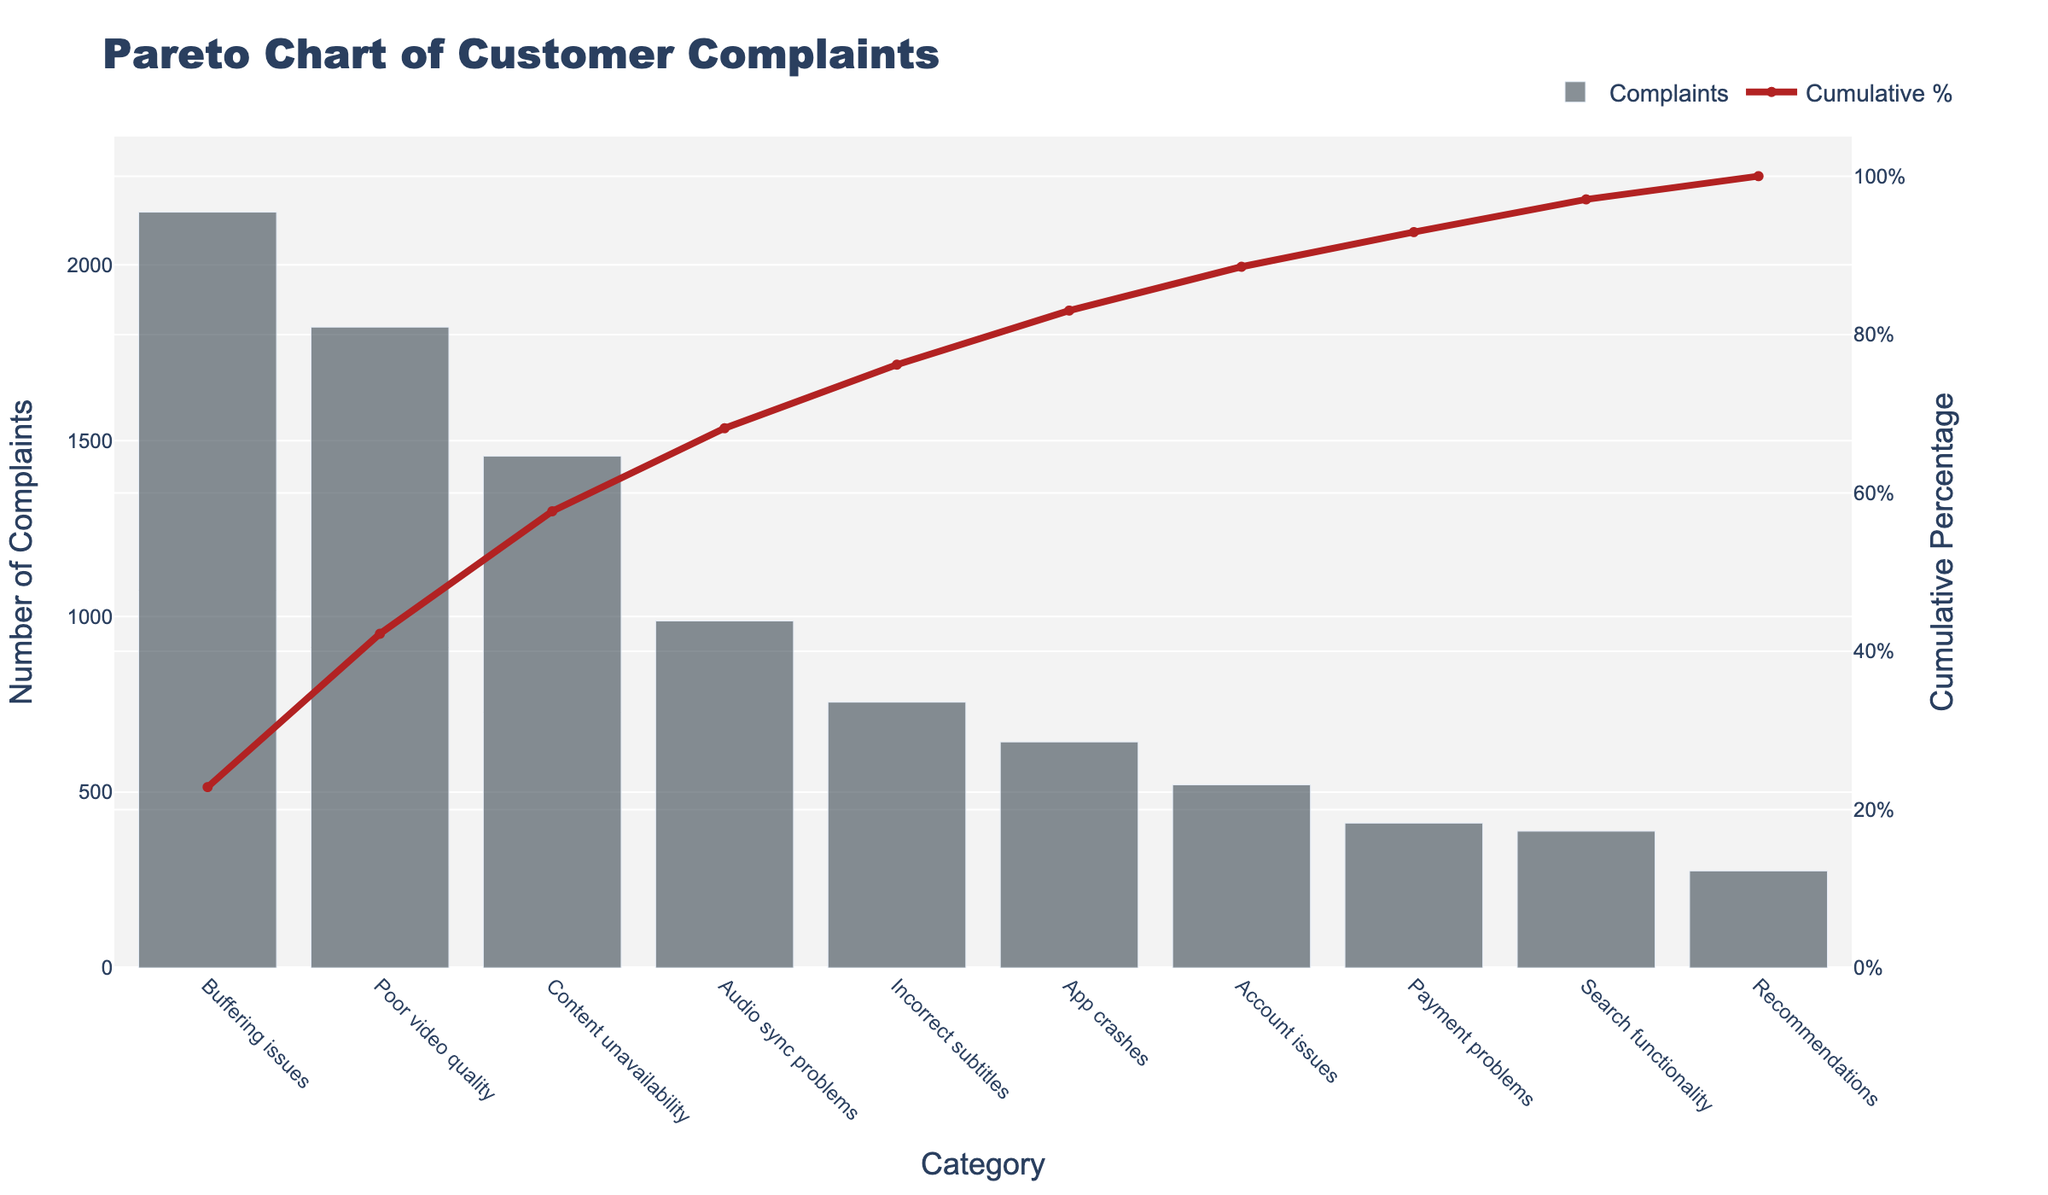What's the title of the figure? The title of the figure is displayed at the top of the chart. It is used to provide an overview of the data being presented.
Answer: Pareto Chart of Customer Complaints How many categories of customer complaints are shown in the chart? Count the number of bars on the x-axis, each representing a category of customer complaints.
Answer: 10 Which category has the highest number of complaints? Look for the tallest bar on the chart, which represents the category with the highest number of complaints.
Answer: Buffering issues What is the cumulative percentage of complaints after the top three categories? Find the cumulative percentage line and check the value where it intersects the third category from the left.
Answer: 52.3% What's the difference in the number of complaints between 'Poor video quality' and 'Audio sync problems'? Subtract the number of complaints for 'Audio sync problems' from the number of complaints for 'Poor video quality'. (1823 - 987)
Answer: 836 Which category surpasses a cumulative percentage of 80%? Follow the cumulative percentage line and see which category (on the x-axis) corresponds to slightly above the 80% mark.
Answer: App crashes How many categories are needed to reach approximately 60% of cumulative complaints? Follow the cumulative percentage line to see how many categories you need to add before reaching 60% on the right y-axis.
Answer: 4 What is the number of complaints for 'Account issues' and what percentage of the total does this represent? Find the bar labelled 'Account issues', read off the number of complaints, then divide this by the total number of complaints and multiply by 100. The total is the sum of all complaints. (521 / 10,413 * 100) ≈ 5%
Answer: 521, approx. 5% If 'Incorrect subtitles' complaints were reduced by half, what would the new count be? Divide the current number of complaints for 'Incorrect subtitles' by 2. (756 / 2)
Answer: 378 How does the number of complaints for 'Search functionality' compare to 'Recommendations'? Look at the heights of the bars for both 'Search functionality' and 'Recommendations' to compare their counts.
Answer: Greater 